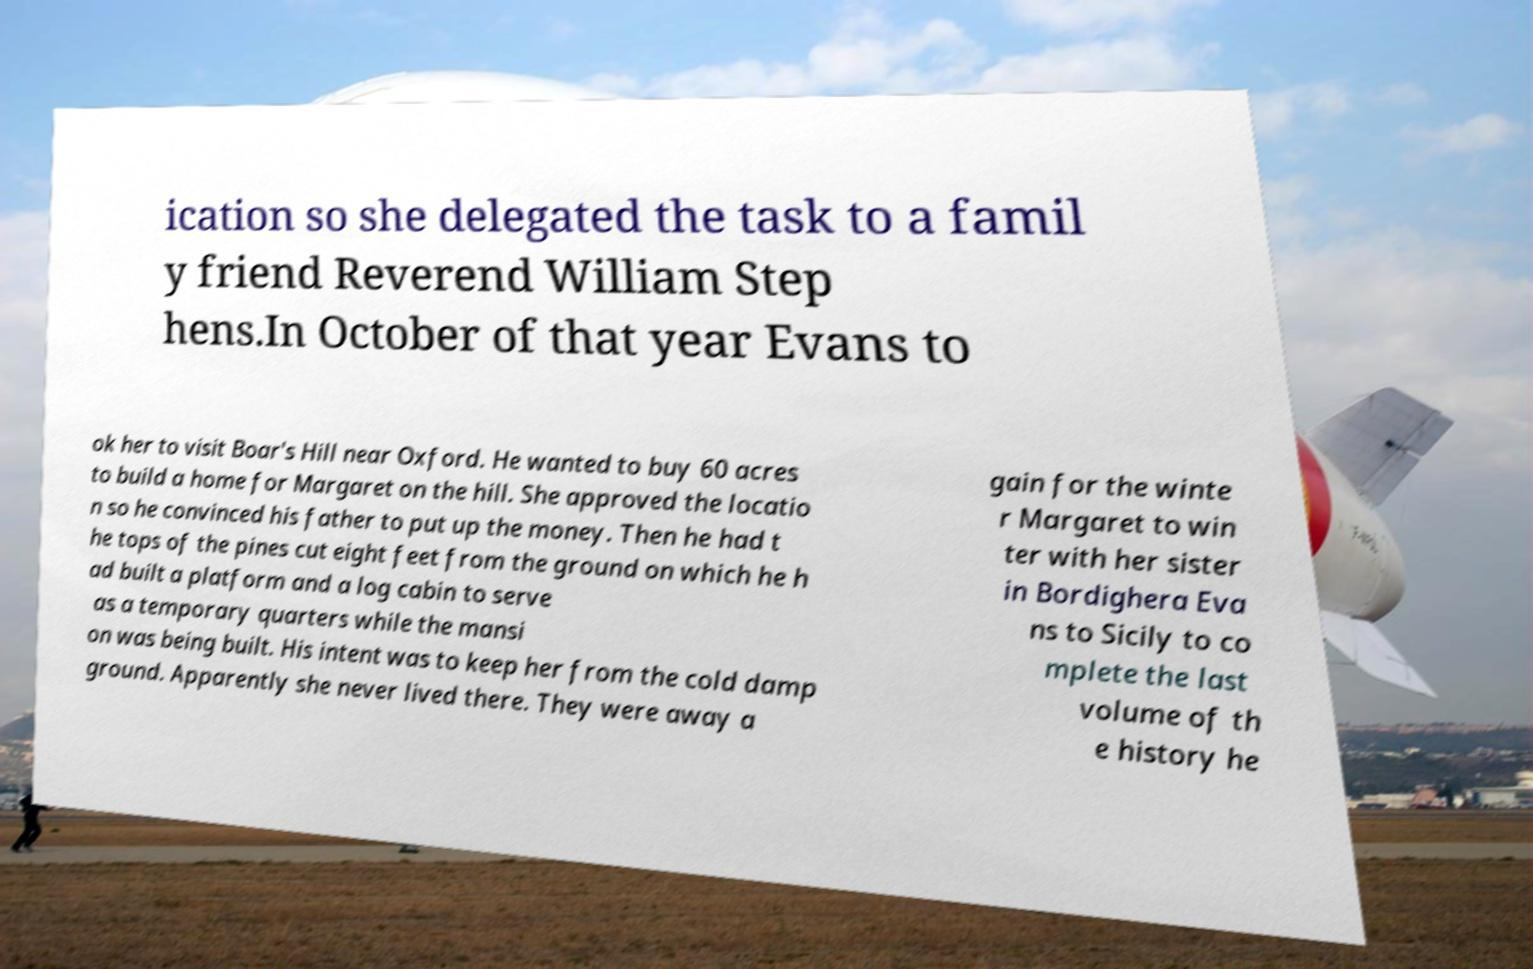There's text embedded in this image that I need extracted. Can you transcribe it verbatim? ication so she delegated the task to a famil y friend Reverend William Step hens.In October of that year Evans to ok her to visit Boar's Hill near Oxford. He wanted to buy 60 acres to build a home for Margaret on the hill. She approved the locatio n so he convinced his father to put up the money. Then he had t he tops of the pines cut eight feet from the ground on which he h ad built a platform and a log cabin to serve as a temporary quarters while the mansi on was being built. His intent was to keep her from the cold damp ground. Apparently she never lived there. They were away a gain for the winte r Margaret to win ter with her sister in Bordighera Eva ns to Sicily to co mplete the last volume of th e history he 